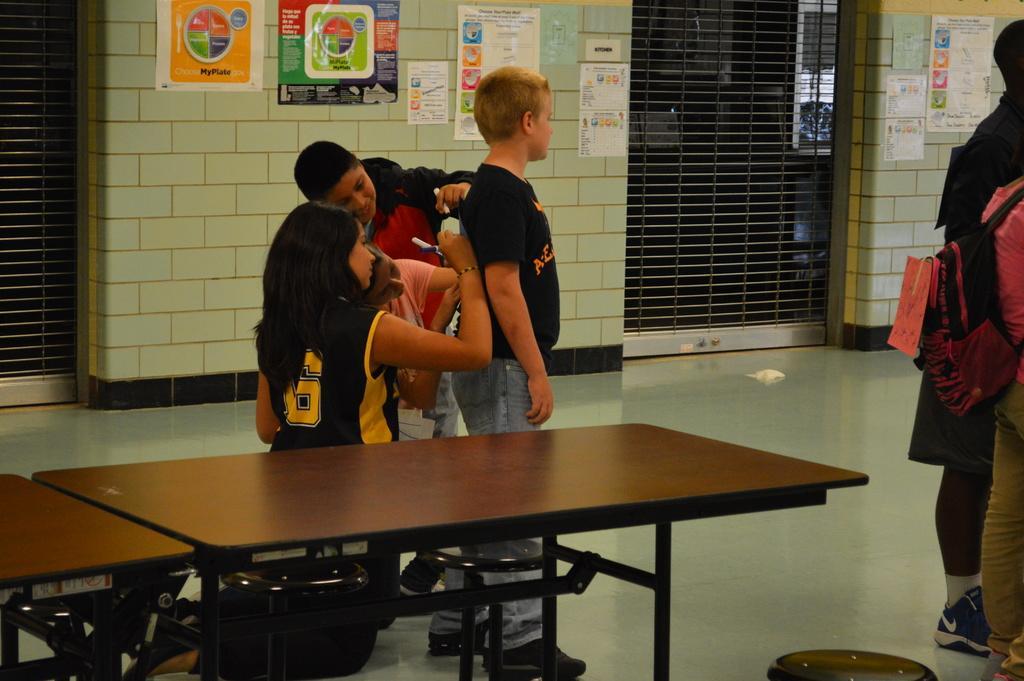Could you give a brief overview of what you see in this image? I think this is a picture of a classroom in a school. There are four children standing in the center of the image and two other to the right, In the center of the image three children are signing on a shirt. In center of the image a child in black shirt is standing. One in the background is smiling and writing something over the black shirt. And this girl sitting she is also writing something over the shirt. In the background on the wall there are some posters stick. On the right background and left background there are shutters. In the center of the image there is a table placed. 